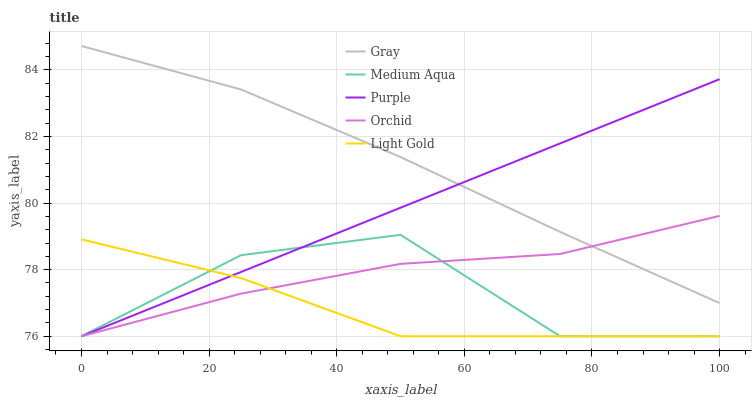Does Light Gold have the minimum area under the curve?
Answer yes or no. Yes. Does Gray have the maximum area under the curve?
Answer yes or no. Yes. Does Gray have the minimum area under the curve?
Answer yes or no. No. Does Light Gold have the maximum area under the curve?
Answer yes or no. No. Is Purple the smoothest?
Answer yes or no. Yes. Is Medium Aqua the roughest?
Answer yes or no. Yes. Is Gray the smoothest?
Answer yes or no. No. Is Gray the roughest?
Answer yes or no. No. Does Purple have the lowest value?
Answer yes or no. Yes. Does Gray have the lowest value?
Answer yes or no. No. Does Gray have the highest value?
Answer yes or no. Yes. Does Light Gold have the highest value?
Answer yes or no. No. Is Light Gold less than Gray?
Answer yes or no. Yes. Is Gray greater than Medium Aqua?
Answer yes or no. Yes. Does Orchid intersect Gray?
Answer yes or no. Yes. Is Orchid less than Gray?
Answer yes or no. No. Is Orchid greater than Gray?
Answer yes or no. No. Does Light Gold intersect Gray?
Answer yes or no. No. 